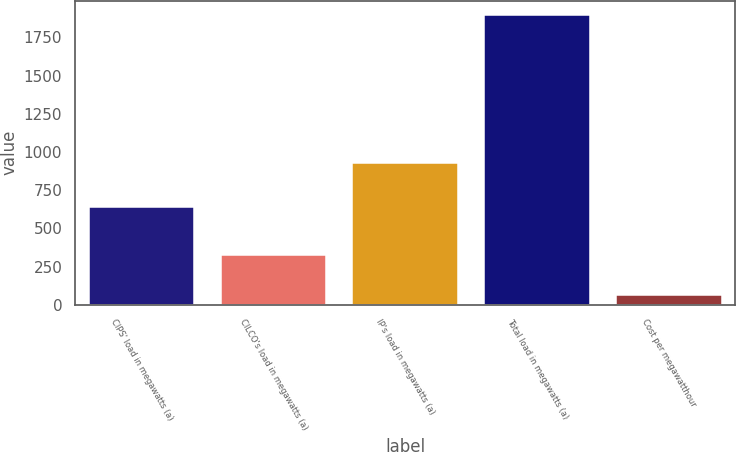<chart> <loc_0><loc_0><loc_500><loc_500><bar_chart><fcel>CIPS' load in megawatts (a)<fcel>CILCO's load in megawatts (a)<fcel>IP's load in megawatts (a)<fcel>Total load in megawatts (a)<fcel>Cost per megawatthour<nl><fcel>639<fcel>328<fcel>928<fcel>1895<fcel>66.05<nl></chart> 